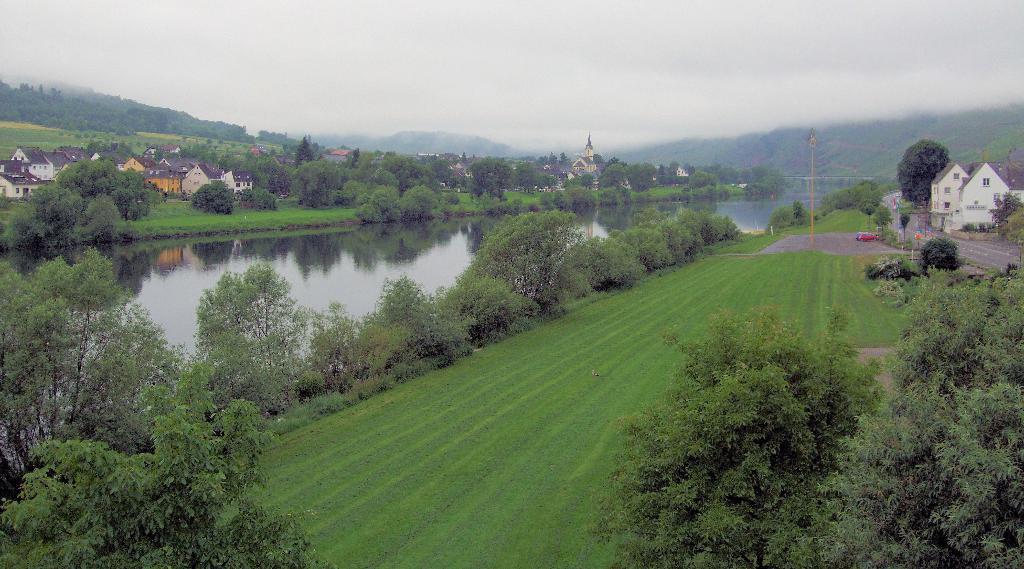Can you describe this image briefly? In this image I can see the ground, some grass on the ground, the water, the road, few vehicles on the ground, few trees which are green in color and few buildings. In the background I can see few buildings, few trees, few mountains and the sky. 